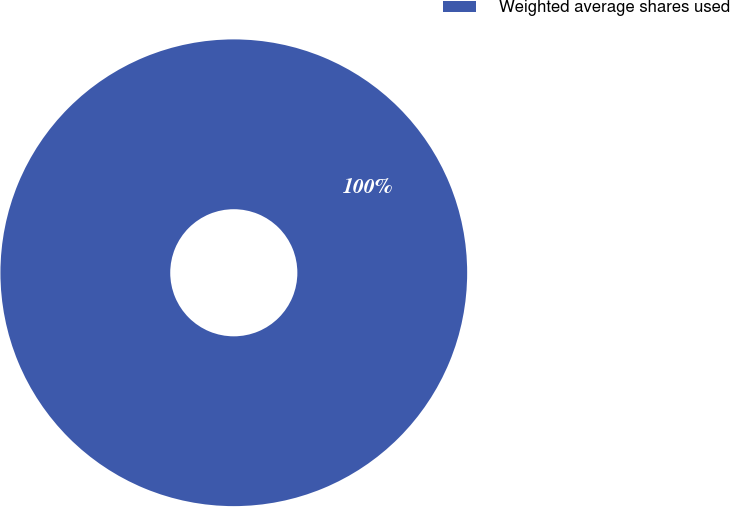Convert chart. <chart><loc_0><loc_0><loc_500><loc_500><pie_chart><fcel>Weighted average shares used<nl><fcel>100.0%<nl></chart> 